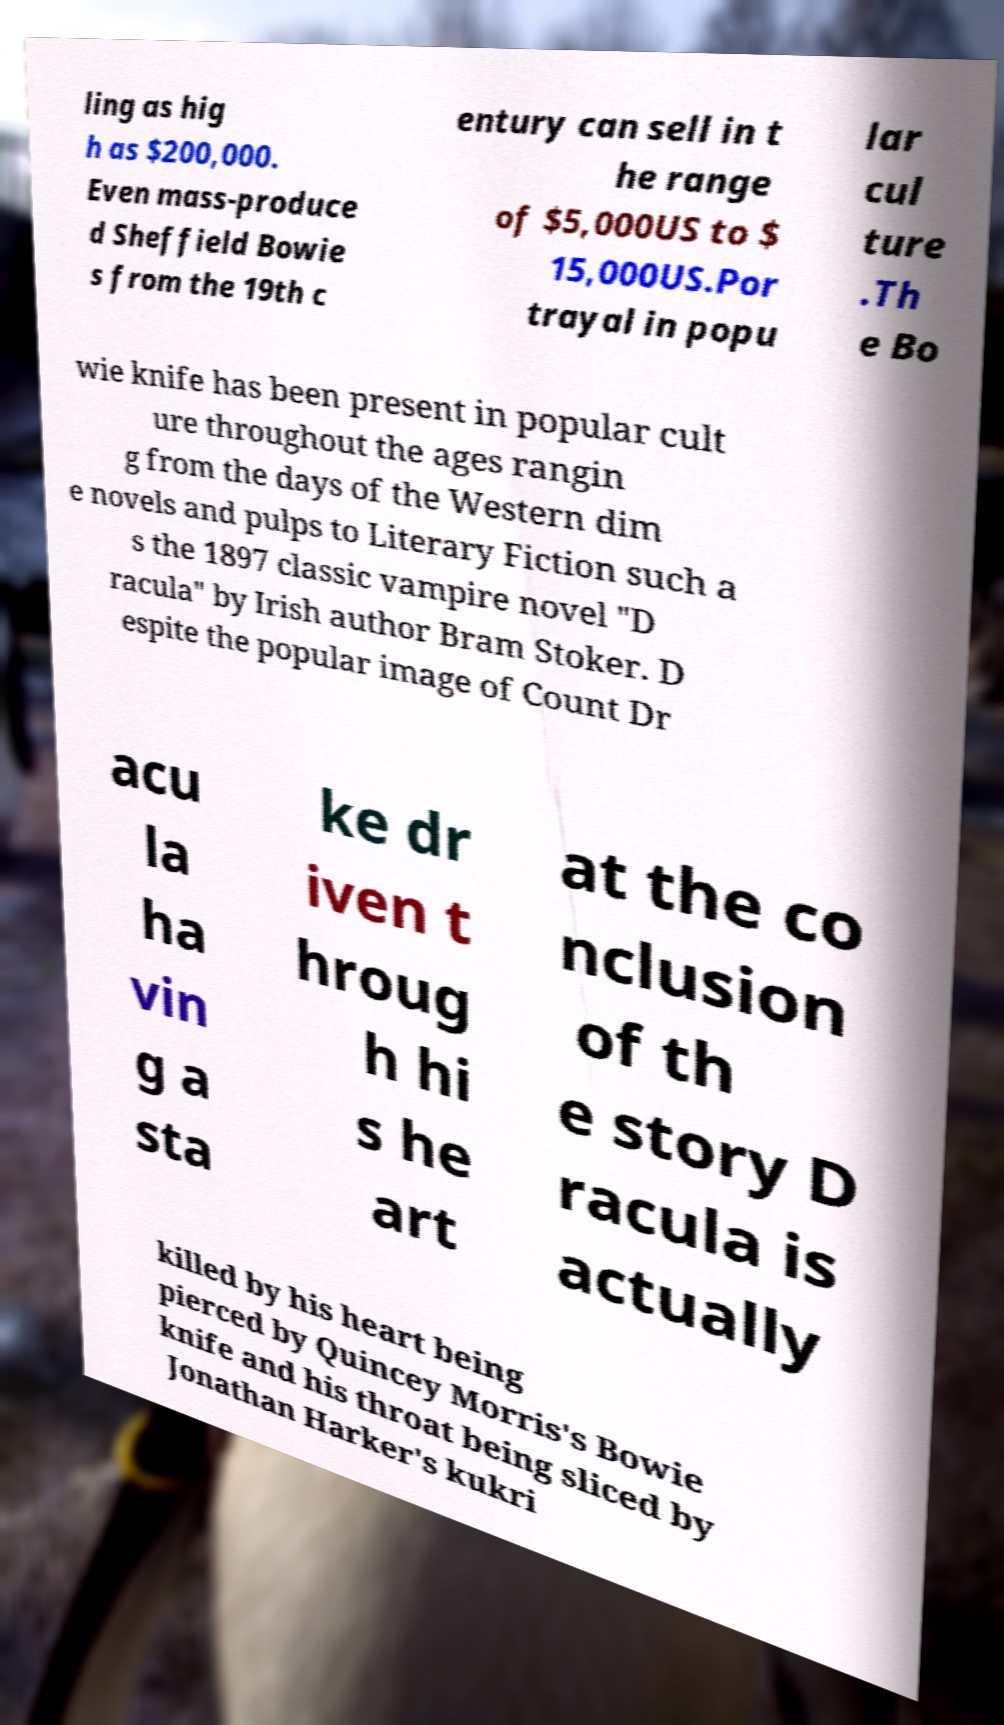Please read and relay the text visible in this image. What does it say? ling as hig h as $200,000. Even mass-produce d Sheffield Bowie s from the 19th c entury can sell in t he range of $5,000US to $ 15,000US.Por trayal in popu lar cul ture .Th e Bo wie knife has been present in popular cult ure throughout the ages rangin g from the days of the Western dim e novels and pulps to Literary Fiction such a s the 1897 classic vampire novel "D racula" by Irish author Bram Stoker. D espite the popular image of Count Dr acu la ha vin g a sta ke dr iven t hroug h hi s he art at the co nclusion of th e story D racula is actually killed by his heart being pierced by Quincey Morris's Bowie knife and his throat being sliced by Jonathan Harker's kukri 